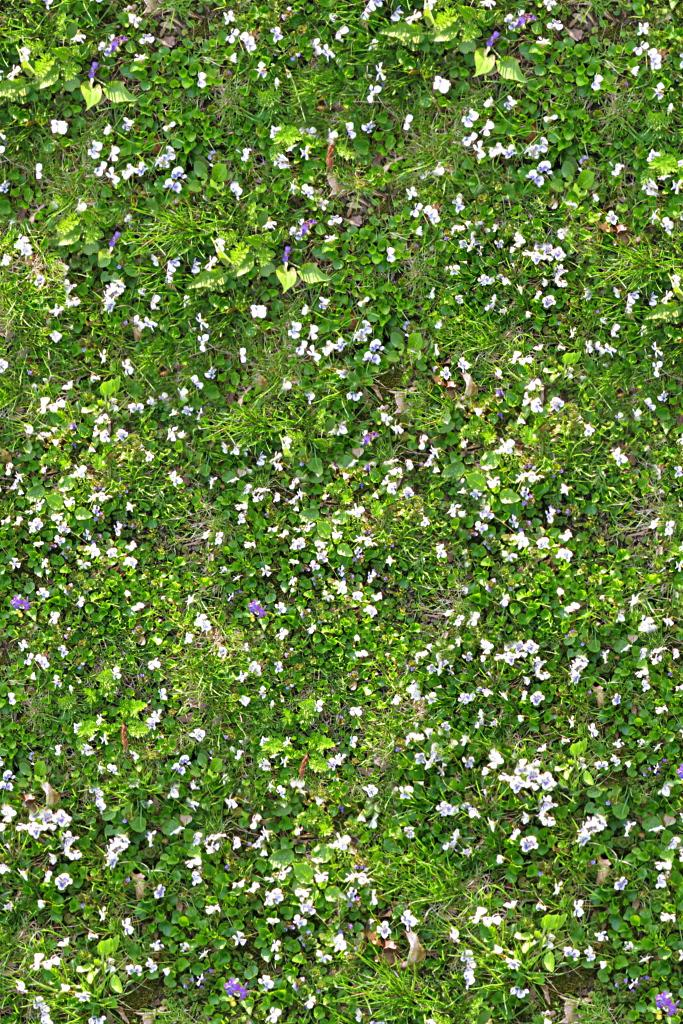What type of living organisms can be seen in the image? There are flowers in the image. What are the flowers growing on? The flowers are on plants. What colors are the flowers in the image? The flowers are in purple and white colors. What type of rail can be seen in the image? There is no rail present in the image; it features flowers on plants in purple and white colors. 